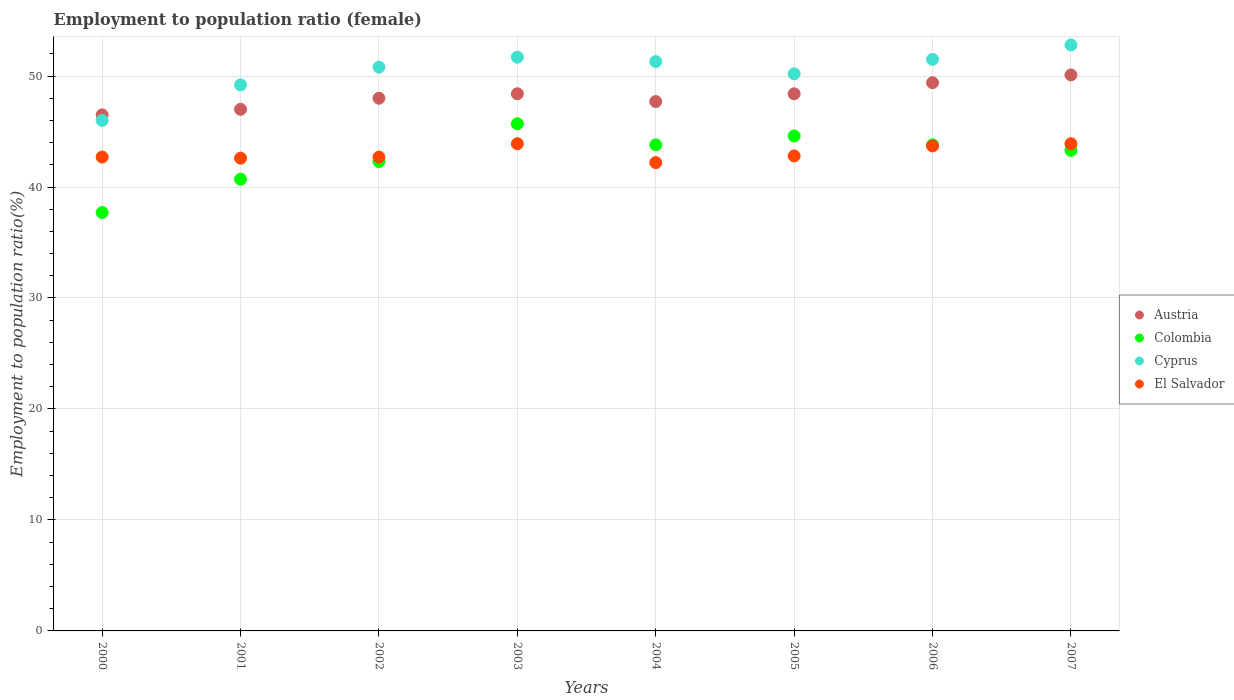How many different coloured dotlines are there?
Provide a succinct answer. 4. Is the number of dotlines equal to the number of legend labels?
Keep it short and to the point. Yes. What is the employment to population ratio in El Salvador in 2004?
Make the answer very short. 42.2. Across all years, what is the maximum employment to population ratio in El Salvador?
Make the answer very short. 43.9. Across all years, what is the minimum employment to population ratio in Colombia?
Offer a very short reply. 37.7. In which year was the employment to population ratio in Colombia maximum?
Offer a terse response. 2003. In which year was the employment to population ratio in Cyprus minimum?
Provide a short and direct response. 2000. What is the total employment to population ratio in El Salvador in the graph?
Provide a short and direct response. 344.5. What is the difference between the employment to population ratio in Cyprus in 2005 and that in 2007?
Your answer should be very brief. -2.6. What is the difference between the employment to population ratio in Colombia in 2006 and the employment to population ratio in El Salvador in 2001?
Make the answer very short. 1.2. What is the average employment to population ratio in Austria per year?
Keep it short and to the point. 48.19. In how many years, is the employment to population ratio in Cyprus greater than 6 %?
Your answer should be compact. 8. What is the ratio of the employment to population ratio in Cyprus in 2003 to that in 2007?
Offer a very short reply. 0.98. What is the difference between the highest and the second highest employment to population ratio in Colombia?
Give a very brief answer. 1.1. What is the difference between the highest and the lowest employment to population ratio in El Salvador?
Give a very brief answer. 1.7. In how many years, is the employment to population ratio in Colombia greater than the average employment to population ratio in Colombia taken over all years?
Offer a terse response. 5. Is it the case that in every year, the sum of the employment to population ratio in Austria and employment to population ratio in Colombia  is greater than the sum of employment to population ratio in Cyprus and employment to population ratio in El Salvador?
Your answer should be compact. No. Is it the case that in every year, the sum of the employment to population ratio in Cyprus and employment to population ratio in Colombia  is greater than the employment to population ratio in Austria?
Ensure brevity in your answer.  Yes. Is the employment to population ratio in El Salvador strictly less than the employment to population ratio in Cyprus over the years?
Your answer should be very brief. Yes. Are the values on the major ticks of Y-axis written in scientific E-notation?
Ensure brevity in your answer.  No. Does the graph contain any zero values?
Your answer should be very brief. No. Does the graph contain grids?
Your answer should be compact. Yes. Where does the legend appear in the graph?
Provide a short and direct response. Center right. How many legend labels are there?
Offer a terse response. 4. What is the title of the graph?
Keep it short and to the point. Employment to population ratio (female). Does "Albania" appear as one of the legend labels in the graph?
Make the answer very short. No. What is the label or title of the Y-axis?
Give a very brief answer. Employment to population ratio(%). What is the Employment to population ratio(%) of Austria in 2000?
Offer a very short reply. 46.5. What is the Employment to population ratio(%) of Colombia in 2000?
Keep it short and to the point. 37.7. What is the Employment to population ratio(%) of El Salvador in 2000?
Provide a short and direct response. 42.7. What is the Employment to population ratio(%) in Colombia in 2001?
Offer a very short reply. 40.7. What is the Employment to population ratio(%) in Cyprus in 2001?
Offer a terse response. 49.2. What is the Employment to population ratio(%) of El Salvador in 2001?
Ensure brevity in your answer.  42.6. What is the Employment to population ratio(%) in Austria in 2002?
Offer a very short reply. 48. What is the Employment to population ratio(%) of Colombia in 2002?
Your response must be concise. 42.3. What is the Employment to population ratio(%) in Cyprus in 2002?
Give a very brief answer. 50.8. What is the Employment to population ratio(%) in El Salvador in 2002?
Your answer should be compact. 42.7. What is the Employment to population ratio(%) of Austria in 2003?
Your response must be concise. 48.4. What is the Employment to population ratio(%) in Colombia in 2003?
Make the answer very short. 45.7. What is the Employment to population ratio(%) of Cyprus in 2003?
Keep it short and to the point. 51.7. What is the Employment to population ratio(%) of El Salvador in 2003?
Your response must be concise. 43.9. What is the Employment to population ratio(%) of Austria in 2004?
Make the answer very short. 47.7. What is the Employment to population ratio(%) of Colombia in 2004?
Your response must be concise. 43.8. What is the Employment to population ratio(%) in Cyprus in 2004?
Your answer should be very brief. 51.3. What is the Employment to population ratio(%) of El Salvador in 2004?
Offer a very short reply. 42.2. What is the Employment to population ratio(%) of Austria in 2005?
Your answer should be very brief. 48.4. What is the Employment to population ratio(%) of Colombia in 2005?
Your response must be concise. 44.6. What is the Employment to population ratio(%) of Cyprus in 2005?
Provide a short and direct response. 50.2. What is the Employment to population ratio(%) in El Salvador in 2005?
Your answer should be compact. 42.8. What is the Employment to population ratio(%) of Austria in 2006?
Offer a terse response. 49.4. What is the Employment to population ratio(%) in Colombia in 2006?
Make the answer very short. 43.8. What is the Employment to population ratio(%) in Cyprus in 2006?
Offer a very short reply. 51.5. What is the Employment to population ratio(%) in El Salvador in 2006?
Your answer should be compact. 43.7. What is the Employment to population ratio(%) of Austria in 2007?
Offer a very short reply. 50.1. What is the Employment to population ratio(%) in Colombia in 2007?
Keep it short and to the point. 43.3. What is the Employment to population ratio(%) of Cyprus in 2007?
Ensure brevity in your answer.  52.8. What is the Employment to population ratio(%) of El Salvador in 2007?
Give a very brief answer. 43.9. Across all years, what is the maximum Employment to population ratio(%) in Austria?
Provide a succinct answer. 50.1. Across all years, what is the maximum Employment to population ratio(%) in Colombia?
Offer a terse response. 45.7. Across all years, what is the maximum Employment to population ratio(%) in Cyprus?
Give a very brief answer. 52.8. Across all years, what is the maximum Employment to population ratio(%) of El Salvador?
Provide a short and direct response. 43.9. Across all years, what is the minimum Employment to population ratio(%) of Austria?
Ensure brevity in your answer.  46.5. Across all years, what is the minimum Employment to population ratio(%) in Colombia?
Your response must be concise. 37.7. Across all years, what is the minimum Employment to population ratio(%) of El Salvador?
Provide a succinct answer. 42.2. What is the total Employment to population ratio(%) in Austria in the graph?
Give a very brief answer. 385.5. What is the total Employment to population ratio(%) of Colombia in the graph?
Your answer should be very brief. 341.9. What is the total Employment to population ratio(%) in Cyprus in the graph?
Give a very brief answer. 403.5. What is the total Employment to population ratio(%) in El Salvador in the graph?
Your response must be concise. 344.5. What is the difference between the Employment to population ratio(%) of Colombia in 2000 and that in 2001?
Provide a short and direct response. -3. What is the difference between the Employment to population ratio(%) of El Salvador in 2000 and that in 2001?
Make the answer very short. 0.1. What is the difference between the Employment to population ratio(%) in Austria in 2000 and that in 2002?
Offer a very short reply. -1.5. What is the difference between the Employment to population ratio(%) of Colombia in 2000 and that in 2003?
Offer a very short reply. -8. What is the difference between the Employment to population ratio(%) of Cyprus in 2000 and that in 2003?
Keep it short and to the point. -5.7. What is the difference between the Employment to population ratio(%) of El Salvador in 2000 and that in 2003?
Offer a very short reply. -1.2. What is the difference between the Employment to population ratio(%) in Colombia in 2000 and that in 2004?
Offer a terse response. -6.1. What is the difference between the Employment to population ratio(%) in Cyprus in 2000 and that in 2004?
Keep it short and to the point. -5.3. What is the difference between the Employment to population ratio(%) of El Salvador in 2000 and that in 2004?
Keep it short and to the point. 0.5. What is the difference between the Employment to population ratio(%) in Austria in 2000 and that in 2005?
Give a very brief answer. -1.9. What is the difference between the Employment to population ratio(%) of El Salvador in 2000 and that in 2005?
Provide a short and direct response. -0.1. What is the difference between the Employment to population ratio(%) in Colombia in 2000 and that in 2006?
Your answer should be very brief. -6.1. What is the difference between the Employment to population ratio(%) in Austria in 2000 and that in 2007?
Your response must be concise. -3.6. What is the difference between the Employment to population ratio(%) of Colombia in 2000 and that in 2007?
Provide a short and direct response. -5.6. What is the difference between the Employment to population ratio(%) of Cyprus in 2000 and that in 2007?
Provide a short and direct response. -6.8. What is the difference between the Employment to population ratio(%) of Austria in 2001 and that in 2002?
Provide a succinct answer. -1. What is the difference between the Employment to population ratio(%) in Cyprus in 2001 and that in 2002?
Your response must be concise. -1.6. What is the difference between the Employment to population ratio(%) in El Salvador in 2001 and that in 2002?
Your answer should be very brief. -0.1. What is the difference between the Employment to population ratio(%) in El Salvador in 2001 and that in 2003?
Your response must be concise. -1.3. What is the difference between the Employment to population ratio(%) of Austria in 2001 and that in 2005?
Offer a terse response. -1.4. What is the difference between the Employment to population ratio(%) of Colombia in 2001 and that in 2005?
Offer a terse response. -3.9. What is the difference between the Employment to population ratio(%) in Colombia in 2001 and that in 2006?
Offer a terse response. -3.1. What is the difference between the Employment to population ratio(%) in Cyprus in 2001 and that in 2006?
Make the answer very short. -2.3. What is the difference between the Employment to population ratio(%) in Austria in 2001 and that in 2007?
Provide a short and direct response. -3.1. What is the difference between the Employment to population ratio(%) in Cyprus in 2001 and that in 2007?
Make the answer very short. -3.6. What is the difference between the Employment to population ratio(%) of El Salvador in 2001 and that in 2007?
Offer a very short reply. -1.3. What is the difference between the Employment to population ratio(%) of Colombia in 2002 and that in 2004?
Your answer should be compact. -1.5. What is the difference between the Employment to population ratio(%) of Cyprus in 2002 and that in 2004?
Provide a succinct answer. -0.5. What is the difference between the Employment to population ratio(%) of El Salvador in 2002 and that in 2004?
Give a very brief answer. 0.5. What is the difference between the Employment to population ratio(%) of Austria in 2002 and that in 2005?
Your answer should be compact. -0.4. What is the difference between the Employment to population ratio(%) of Colombia in 2002 and that in 2005?
Offer a terse response. -2.3. What is the difference between the Employment to population ratio(%) in Cyprus in 2002 and that in 2005?
Keep it short and to the point. 0.6. What is the difference between the Employment to population ratio(%) of El Salvador in 2002 and that in 2005?
Offer a very short reply. -0.1. What is the difference between the Employment to population ratio(%) in Austria in 2002 and that in 2006?
Keep it short and to the point. -1.4. What is the difference between the Employment to population ratio(%) in Cyprus in 2002 and that in 2006?
Give a very brief answer. -0.7. What is the difference between the Employment to population ratio(%) in Austria in 2002 and that in 2007?
Provide a short and direct response. -2.1. What is the difference between the Employment to population ratio(%) of Colombia in 2002 and that in 2007?
Provide a succinct answer. -1. What is the difference between the Employment to population ratio(%) in El Salvador in 2002 and that in 2007?
Your answer should be compact. -1.2. What is the difference between the Employment to population ratio(%) of Austria in 2003 and that in 2004?
Make the answer very short. 0.7. What is the difference between the Employment to population ratio(%) in Cyprus in 2003 and that in 2004?
Ensure brevity in your answer.  0.4. What is the difference between the Employment to population ratio(%) of Austria in 2003 and that in 2005?
Keep it short and to the point. 0. What is the difference between the Employment to population ratio(%) of Colombia in 2003 and that in 2005?
Your response must be concise. 1.1. What is the difference between the Employment to population ratio(%) of Austria in 2003 and that in 2006?
Give a very brief answer. -1. What is the difference between the Employment to population ratio(%) in Colombia in 2003 and that in 2006?
Provide a short and direct response. 1.9. What is the difference between the Employment to population ratio(%) of Cyprus in 2003 and that in 2006?
Your response must be concise. 0.2. What is the difference between the Employment to population ratio(%) in El Salvador in 2003 and that in 2006?
Offer a very short reply. 0.2. What is the difference between the Employment to population ratio(%) in Cyprus in 2003 and that in 2007?
Your response must be concise. -1.1. What is the difference between the Employment to population ratio(%) of El Salvador in 2003 and that in 2007?
Offer a terse response. 0. What is the difference between the Employment to population ratio(%) in El Salvador in 2004 and that in 2005?
Ensure brevity in your answer.  -0.6. What is the difference between the Employment to population ratio(%) in Austria in 2004 and that in 2006?
Make the answer very short. -1.7. What is the difference between the Employment to population ratio(%) of Cyprus in 2004 and that in 2006?
Provide a short and direct response. -0.2. What is the difference between the Employment to population ratio(%) of Austria in 2004 and that in 2007?
Your response must be concise. -2.4. What is the difference between the Employment to population ratio(%) in Colombia in 2004 and that in 2007?
Ensure brevity in your answer.  0.5. What is the difference between the Employment to population ratio(%) in Austria in 2005 and that in 2006?
Offer a very short reply. -1. What is the difference between the Employment to population ratio(%) of Colombia in 2005 and that in 2006?
Keep it short and to the point. 0.8. What is the difference between the Employment to population ratio(%) of El Salvador in 2005 and that in 2006?
Give a very brief answer. -0.9. What is the difference between the Employment to population ratio(%) in Colombia in 2005 and that in 2007?
Ensure brevity in your answer.  1.3. What is the difference between the Employment to population ratio(%) in Austria in 2006 and that in 2007?
Keep it short and to the point. -0.7. What is the difference between the Employment to population ratio(%) of El Salvador in 2006 and that in 2007?
Offer a very short reply. -0.2. What is the difference between the Employment to population ratio(%) in Colombia in 2000 and the Employment to population ratio(%) in El Salvador in 2001?
Your response must be concise. -4.9. What is the difference between the Employment to population ratio(%) of Cyprus in 2000 and the Employment to population ratio(%) of El Salvador in 2001?
Your response must be concise. 3.4. What is the difference between the Employment to population ratio(%) of Austria in 2000 and the Employment to population ratio(%) of Cyprus in 2003?
Your answer should be very brief. -5.2. What is the difference between the Employment to population ratio(%) in Colombia in 2000 and the Employment to population ratio(%) in El Salvador in 2003?
Provide a short and direct response. -6.2. What is the difference between the Employment to population ratio(%) of Cyprus in 2000 and the Employment to population ratio(%) of El Salvador in 2004?
Offer a terse response. 3.8. What is the difference between the Employment to population ratio(%) in Austria in 2000 and the Employment to population ratio(%) in Colombia in 2005?
Offer a terse response. 1.9. What is the difference between the Employment to population ratio(%) of Austria in 2000 and the Employment to population ratio(%) of El Salvador in 2005?
Make the answer very short. 3.7. What is the difference between the Employment to population ratio(%) of Colombia in 2000 and the Employment to population ratio(%) of Cyprus in 2005?
Ensure brevity in your answer.  -12.5. What is the difference between the Employment to population ratio(%) of Colombia in 2000 and the Employment to population ratio(%) of El Salvador in 2005?
Offer a very short reply. -5.1. What is the difference between the Employment to population ratio(%) of Austria in 2000 and the Employment to population ratio(%) of Cyprus in 2006?
Your answer should be very brief. -5. What is the difference between the Employment to population ratio(%) of Austria in 2000 and the Employment to population ratio(%) of El Salvador in 2006?
Your answer should be very brief. 2.8. What is the difference between the Employment to population ratio(%) in Colombia in 2000 and the Employment to population ratio(%) in Cyprus in 2006?
Keep it short and to the point. -13.8. What is the difference between the Employment to population ratio(%) in Austria in 2000 and the Employment to population ratio(%) in Colombia in 2007?
Offer a very short reply. 3.2. What is the difference between the Employment to population ratio(%) in Austria in 2000 and the Employment to population ratio(%) in El Salvador in 2007?
Your answer should be compact. 2.6. What is the difference between the Employment to population ratio(%) in Colombia in 2000 and the Employment to population ratio(%) in Cyprus in 2007?
Provide a succinct answer. -15.1. What is the difference between the Employment to population ratio(%) of Austria in 2001 and the Employment to population ratio(%) of Colombia in 2002?
Provide a short and direct response. 4.7. What is the difference between the Employment to population ratio(%) in Austria in 2001 and the Employment to population ratio(%) in Cyprus in 2002?
Your answer should be very brief. -3.8. What is the difference between the Employment to population ratio(%) in Colombia in 2001 and the Employment to population ratio(%) in Cyprus in 2002?
Your answer should be very brief. -10.1. What is the difference between the Employment to population ratio(%) in Cyprus in 2001 and the Employment to population ratio(%) in El Salvador in 2002?
Provide a short and direct response. 6.5. What is the difference between the Employment to population ratio(%) in Cyprus in 2001 and the Employment to population ratio(%) in El Salvador in 2003?
Your response must be concise. 5.3. What is the difference between the Employment to population ratio(%) of Austria in 2001 and the Employment to population ratio(%) of Cyprus in 2004?
Provide a short and direct response. -4.3. What is the difference between the Employment to population ratio(%) of Colombia in 2001 and the Employment to population ratio(%) of El Salvador in 2004?
Ensure brevity in your answer.  -1.5. What is the difference between the Employment to population ratio(%) of Austria in 2001 and the Employment to population ratio(%) of Cyprus in 2005?
Make the answer very short. -3.2. What is the difference between the Employment to population ratio(%) of Austria in 2001 and the Employment to population ratio(%) of El Salvador in 2005?
Give a very brief answer. 4.2. What is the difference between the Employment to population ratio(%) in Colombia in 2001 and the Employment to population ratio(%) in Cyprus in 2005?
Offer a terse response. -9.5. What is the difference between the Employment to population ratio(%) in Colombia in 2001 and the Employment to population ratio(%) in El Salvador in 2005?
Your answer should be compact. -2.1. What is the difference between the Employment to population ratio(%) in Cyprus in 2001 and the Employment to population ratio(%) in El Salvador in 2005?
Your answer should be very brief. 6.4. What is the difference between the Employment to population ratio(%) in Austria in 2001 and the Employment to population ratio(%) in Colombia in 2006?
Keep it short and to the point. 3.2. What is the difference between the Employment to population ratio(%) of Austria in 2001 and the Employment to population ratio(%) of El Salvador in 2006?
Offer a terse response. 3.3. What is the difference between the Employment to population ratio(%) in Colombia in 2001 and the Employment to population ratio(%) in Cyprus in 2006?
Give a very brief answer. -10.8. What is the difference between the Employment to population ratio(%) in Cyprus in 2001 and the Employment to population ratio(%) in El Salvador in 2006?
Make the answer very short. 5.5. What is the difference between the Employment to population ratio(%) of Austria in 2001 and the Employment to population ratio(%) of Cyprus in 2007?
Offer a very short reply. -5.8. What is the difference between the Employment to population ratio(%) of Austria in 2001 and the Employment to population ratio(%) of El Salvador in 2007?
Your response must be concise. 3.1. What is the difference between the Employment to population ratio(%) of Colombia in 2001 and the Employment to population ratio(%) of Cyprus in 2007?
Your response must be concise. -12.1. What is the difference between the Employment to population ratio(%) of Cyprus in 2001 and the Employment to population ratio(%) of El Salvador in 2007?
Provide a succinct answer. 5.3. What is the difference between the Employment to population ratio(%) of Austria in 2002 and the Employment to population ratio(%) of Cyprus in 2003?
Ensure brevity in your answer.  -3.7. What is the difference between the Employment to population ratio(%) in Austria in 2002 and the Employment to population ratio(%) in El Salvador in 2003?
Your answer should be compact. 4.1. What is the difference between the Employment to population ratio(%) of Colombia in 2002 and the Employment to population ratio(%) of El Salvador in 2003?
Offer a very short reply. -1.6. What is the difference between the Employment to population ratio(%) of Austria in 2002 and the Employment to population ratio(%) of Cyprus in 2004?
Provide a succinct answer. -3.3. What is the difference between the Employment to population ratio(%) of Colombia in 2002 and the Employment to population ratio(%) of Cyprus in 2004?
Offer a terse response. -9. What is the difference between the Employment to population ratio(%) in Colombia in 2002 and the Employment to population ratio(%) in El Salvador in 2004?
Make the answer very short. 0.1. What is the difference between the Employment to population ratio(%) of Austria in 2002 and the Employment to population ratio(%) of Colombia in 2006?
Make the answer very short. 4.2. What is the difference between the Employment to population ratio(%) in Austria in 2002 and the Employment to population ratio(%) in Cyprus in 2006?
Offer a very short reply. -3.5. What is the difference between the Employment to population ratio(%) of Colombia in 2002 and the Employment to population ratio(%) of El Salvador in 2006?
Offer a very short reply. -1.4. What is the difference between the Employment to population ratio(%) of Cyprus in 2002 and the Employment to population ratio(%) of El Salvador in 2006?
Your answer should be compact. 7.1. What is the difference between the Employment to population ratio(%) in Austria in 2002 and the Employment to population ratio(%) in Colombia in 2007?
Provide a short and direct response. 4.7. What is the difference between the Employment to population ratio(%) of Austria in 2002 and the Employment to population ratio(%) of Cyprus in 2007?
Your answer should be compact. -4.8. What is the difference between the Employment to population ratio(%) of Austria in 2002 and the Employment to population ratio(%) of El Salvador in 2007?
Offer a very short reply. 4.1. What is the difference between the Employment to population ratio(%) in Colombia in 2002 and the Employment to population ratio(%) in Cyprus in 2007?
Keep it short and to the point. -10.5. What is the difference between the Employment to population ratio(%) of Austria in 2003 and the Employment to population ratio(%) of Colombia in 2004?
Your answer should be very brief. 4.6. What is the difference between the Employment to population ratio(%) of Austria in 2003 and the Employment to population ratio(%) of El Salvador in 2004?
Your response must be concise. 6.2. What is the difference between the Employment to population ratio(%) of Colombia in 2003 and the Employment to population ratio(%) of Cyprus in 2004?
Offer a very short reply. -5.6. What is the difference between the Employment to population ratio(%) of Colombia in 2003 and the Employment to population ratio(%) of El Salvador in 2004?
Give a very brief answer. 3.5. What is the difference between the Employment to population ratio(%) of Austria in 2003 and the Employment to population ratio(%) of El Salvador in 2005?
Your response must be concise. 5.6. What is the difference between the Employment to population ratio(%) in Cyprus in 2003 and the Employment to population ratio(%) in El Salvador in 2005?
Offer a terse response. 8.9. What is the difference between the Employment to population ratio(%) in Colombia in 2003 and the Employment to population ratio(%) in El Salvador in 2006?
Offer a terse response. 2. What is the difference between the Employment to population ratio(%) in Austria in 2003 and the Employment to population ratio(%) in Colombia in 2007?
Keep it short and to the point. 5.1. What is the difference between the Employment to population ratio(%) of Austria in 2003 and the Employment to population ratio(%) of Cyprus in 2007?
Your answer should be compact. -4.4. What is the difference between the Employment to population ratio(%) of Austria in 2003 and the Employment to population ratio(%) of El Salvador in 2007?
Ensure brevity in your answer.  4.5. What is the difference between the Employment to population ratio(%) of Colombia in 2003 and the Employment to population ratio(%) of El Salvador in 2007?
Offer a very short reply. 1.8. What is the difference between the Employment to population ratio(%) of Cyprus in 2003 and the Employment to population ratio(%) of El Salvador in 2007?
Keep it short and to the point. 7.8. What is the difference between the Employment to population ratio(%) of Austria in 2004 and the Employment to population ratio(%) of Colombia in 2005?
Ensure brevity in your answer.  3.1. What is the difference between the Employment to population ratio(%) in Austria in 2004 and the Employment to population ratio(%) in Cyprus in 2005?
Keep it short and to the point. -2.5. What is the difference between the Employment to population ratio(%) in Colombia in 2004 and the Employment to population ratio(%) in Cyprus in 2005?
Give a very brief answer. -6.4. What is the difference between the Employment to population ratio(%) in Colombia in 2004 and the Employment to population ratio(%) in El Salvador in 2005?
Ensure brevity in your answer.  1. What is the difference between the Employment to population ratio(%) in Cyprus in 2004 and the Employment to population ratio(%) in El Salvador in 2005?
Keep it short and to the point. 8.5. What is the difference between the Employment to population ratio(%) of Austria in 2004 and the Employment to population ratio(%) of Colombia in 2006?
Ensure brevity in your answer.  3.9. What is the difference between the Employment to population ratio(%) in Colombia in 2004 and the Employment to population ratio(%) in Cyprus in 2006?
Your response must be concise. -7.7. What is the difference between the Employment to population ratio(%) in Colombia in 2004 and the Employment to population ratio(%) in El Salvador in 2006?
Offer a terse response. 0.1. What is the difference between the Employment to population ratio(%) in Cyprus in 2004 and the Employment to population ratio(%) in El Salvador in 2007?
Provide a short and direct response. 7.4. What is the difference between the Employment to population ratio(%) in Austria in 2005 and the Employment to population ratio(%) in Colombia in 2006?
Ensure brevity in your answer.  4.6. What is the difference between the Employment to population ratio(%) of Austria in 2005 and the Employment to population ratio(%) of El Salvador in 2006?
Provide a succinct answer. 4.7. What is the difference between the Employment to population ratio(%) in Colombia in 2005 and the Employment to population ratio(%) in Cyprus in 2006?
Your answer should be very brief. -6.9. What is the difference between the Employment to population ratio(%) of Colombia in 2005 and the Employment to population ratio(%) of El Salvador in 2006?
Provide a succinct answer. 0.9. What is the difference between the Employment to population ratio(%) in Cyprus in 2005 and the Employment to population ratio(%) in El Salvador in 2006?
Offer a very short reply. 6.5. What is the difference between the Employment to population ratio(%) in Austria in 2005 and the Employment to population ratio(%) in Cyprus in 2007?
Give a very brief answer. -4.4. What is the difference between the Employment to population ratio(%) in Austria in 2005 and the Employment to population ratio(%) in El Salvador in 2007?
Your answer should be very brief. 4.5. What is the difference between the Employment to population ratio(%) of Colombia in 2005 and the Employment to population ratio(%) of Cyprus in 2007?
Offer a very short reply. -8.2. What is the difference between the Employment to population ratio(%) in Colombia in 2005 and the Employment to population ratio(%) in El Salvador in 2007?
Give a very brief answer. 0.7. What is the difference between the Employment to population ratio(%) of Cyprus in 2005 and the Employment to population ratio(%) of El Salvador in 2007?
Keep it short and to the point. 6.3. What is the difference between the Employment to population ratio(%) in Austria in 2006 and the Employment to population ratio(%) in Cyprus in 2007?
Keep it short and to the point. -3.4. What is the difference between the Employment to population ratio(%) of Cyprus in 2006 and the Employment to population ratio(%) of El Salvador in 2007?
Give a very brief answer. 7.6. What is the average Employment to population ratio(%) in Austria per year?
Offer a very short reply. 48.19. What is the average Employment to population ratio(%) of Colombia per year?
Your answer should be very brief. 42.74. What is the average Employment to population ratio(%) in Cyprus per year?
Your answer should be compact. 50.44. What is the average Employment to population ratio(%) in El Salvador per year?
Your answer should be very brief. 43.06. In the year 2000, what is the difference between the Employment to population ratio(%) of Austria and Employment to population ratio(%) of Colombia?
Keep it short and to the point. 8.8. In the year 2000, what is the difference between the Employment to population ratio(%) of Cyprus and Employment to population ratio(%) of El Salvador?
Make the answer very short. 3.3. In the year 2001, what is the difference between the Employment to population ratio(%) of Austria and Employment to population ratio(%) of Cyprus?
Provide a short and direct response. -2.2. In the year 2001, what is the difference between the Employment to population ratio(%) of Colombia and Employment to population ratio(%) of Cyprus?
Offer a terse response. -8.5. In the year 2001, what is the difference between the Employment to population ratio(%) of Cyprus and Employment to population ratio(%) of El Salvador?
Give a very brief answer. 6.6. In the year 2002, what is the difference between the Employment to population ratio(%) of Austria and Employment to population ratio(%) of El Salvador?
Offer a terse response. 5.3. In the year 2002, what is the difference between the Employment to population ratio(%) of Colombia and Employment to population ratio(%) of Cyprus?
Offer a very short reply. -8.5. In the year 2002, what is the difference between the Employment to population ratio(%) of Cyprus and Employment to population ratio(%) of El Salvador?
Provide a short and direct response. 8.1. In the year 2003, what is the difference between the Employment to population ratio(%) in Austria and Employment to population ratio(%) in Cyprus?
Your answer should be very brief. -3.3. In the year 2003, what is the difference between the Employment to population ratio(%) in Colombia and Employment to population ratio(%) in Cyprus?
Your answer should be very brief. -6. In the year 2003, what is the difference between the Employment to population ratio(%) in Colombia and Employment to population ratio(%) in El Salvador?
Your answer should be compact. 1.8. In the year 2004, what is the difference between the Employment to population ratio(%) of Austria and Employment to population ratio(%) of Cyprus?
Your response must be concise. -3.6. In the year 2004, what is the difference between the Employment to population ratio(%) of Austria and Employment to population ratio(%) of El Salvador?
Keep it short and to the point. 5.5. In the year 2004, what is the difference between the Employment to population ratio(%) of Colombia and Employment to population ratio(%) of Cyprus?
Your answer should be very brief. -7.5. In the year 2004, what is the difference between the Employment to population ratio(%) of Colombia and Employment to population ratio(%) of El Salvador?
Make the answer very short. 1.6. In the year 2004, what is the difference between the Employment to population ratio(%) of Cyprus and Employment to population ratio(%) of El Salvador?
Give a very brief answer. 9.1. In the year 2005, what is the difference between the Employment to population ratio(%) of Austria and Employment to population ratio(%) of Colombia?
Make the answer very short. 3.8. In the year 2005, what is the difference between the Employment to population ratio(%) of Austria and Employment to population ratio(%) of Cyprus?
Your answer should be very brief. -1.8. In the year 2005, what is the difference between the Employment to population ratio(%) in Colombia and Employment to population ratio(%) in Cyprus?
Provide a short and direct response. -5.6. In the year 2006, what is the difference between the Employment to population ratio(%) in Austria and Employment to population ratio(%) in Colombia?
Keep it short and to the point. 5.6. In the year 2006, what is the difference between the Employment to population ratio(%) of Austria and Employment to population ratio(%) of Cyprus?
Give a very brief answer. -2.1. In the year 2006, what is the difference between the Employment to population ratio(%) of Colombia and Employment to population ratio(%) of Cyprus?
Provide a short and direct response. -7.7. In the year 2006, what is the difference between the Employment to population ratio(%) in Cyprus and Employment to population ratio(%) in El Salvador?
Ensure brevity in your answer.  7.8. In the year 2007, what is the difference between the Employment to population ratio(%) of Austria and Employment to population ratio(%) of Cyprus?
Make the answer very short. -2.7. In the year 2007, what is the difference between the Employment to population ratio(%) of Cyprus and Employment to population ratio(%) of El Salvador?
Provide a succinct answer. 8.9. What is the ratio of the Employment to population ratio(%) in Austria in 2000 to that in 2001?
Your answer should be compact. 0.99. What is the ratio of the Employment to population ratio(%) of Colombia in 2000 to that in 2001?
Make the answer very short. 0.93. What is the ratio of the Employment to population ratio(%) in Cyprus in 2000 to that in 2001?
Your answer should be very brief. 0.94. What is the ratio of the Employment to population ratio(%) in Austria in 2000 to that in 2002?
Your answer should be compact. 0.97. What is the ratio of the Employment to population ratio(%) of Colombia in 2000 to that in 2002?
Give a very brief answer. 0.89. What is the ratio of the Employment to population ratio(%) in Cyprus in 2000 to that in 2002?
Your response must be concise. 0.91. What is the ratio of the Employment to population ratio(%) of El Salvador in 2000 to that in 2002?
Your response must be concise. 1. What is the ratio of the Employment to population ratio(%) of Austria in 2000 to that in 2003?
Your answer should be compact. 0.96. What is the ratio of the Employment to population ratio(%) in Colombia in 2000 to that in 2003?
Your response must be concise. 0.82. What is the ratio of the Employment to population ratio(%) of Cyprus in 2000 to that in 2003?
Ensure brevity in your answer.  0.89. What is the ratio of the Employment to population ratio(%) in El Salvador in 2000 to that in 2003?
Your answer should be very brief. 0.97. What is the ratio of the Employment to population ratio(%) of Austria in 2000 to that in 2004?
Your answer should be compact. 0.97. What is the ratio of the Employment to population ratio(%) of Colombia in 2000 to that in 2004?
Offer a very short reply. 0.86. What is the ratio of the Employment to population ratio(%) of Cyprus in 2000 to that in 2004?
Make the answer very short. 0.9. What is the ratio of the Employment to population ratio(%) in El Salvador in 2000 to that in 2004?
Your answer should be compact. 1.01. What is the ratio of the Employment to population ratio(%) in Austria in 2000 to that in 2005?
Provide a short and direct response. 0.96. What is the ratio of the Employment to population ratio(%) of Colombia in 2000 to that in 2005?
Ensure brevity in your answer.  0.85. What is the ratio of the Employment to population ratio(%) in Cyprus in 2000 to that in 2005?
Provide a succinct answer. 0.92. What is the ratio of the Employment to population ratio(%) of Austria in 2000 to that in 2006?
Provide a short and direct response. 0.94. What is the ratio of the Employment to population ratio(%) in Colombia in 2000 to that in 2006?
Your answer should be very brief. 0.86. What is the ratio of the Employment to population ratio(%) in Cyprus in 2000 to that in 2006?
Your response must be concise. 0.89. What is the ratio of the Employment to population ratio(%) in El Salvador in 2000 to that in 2006?
Your answer should be very brief. 0.98. What is the ratio of the Employment to population ratio(%) in Austria in 2000 to that in 2007?
Ensure brevity in your answer.  0.93. What is the ratio of the Employment to population ratio(%) of Colombia in 2000 to that in 2007?
Make the answer very short. 0.87. What is the ratio of the Employment to population ratio(%) of Cyprus in 2000 to that in 2007?
Ensure brevity in your answer.  0.87. What is the ratio of the Employment to population ratio(%) of El Salvador in 2000 to that in 2007?
Your answer should be very brief. 0.97. What is the ratio of the Employment to population ratio(%) of Austria in 2001 to that in 2002?
Provide a short and direct response. 0.98. What is the ratio of the Employment to population ratio(%) in Colombia in 2001 to that in 2002?
Your response must be concise. 0.96. What is the ratio of the Employment to population ratio(%) in Cyprus in 2001 to that in 2002?
Provide a succinct answer. 0.97. What is the ratio of the Employment to population ratio(%) in Austria in 2001 to that in 2003?
Offer a very short reply. 0.97. What is the ratio of the Employment to population ratio(%) in Colombia in 2001 to that in 2003?
Provide a succinct answer. 0.89. What is the ratio of the Employment to population ratio(%) in Cyprus in 2001 to that in 2003?
Ensure brevity in your answer.  0.95. What is the ratio of the Employment to population ratio(%) of El Salvador in 2001 to that in 2003?
Give a very brief answer. 0.97. What is the ratio of the Employment to population ratio(%) of Austria in 2001 to that in 2004?
Keep it short and to the point. 0.99. What is the ratio of the Employment to population ratio(%) in Colombia in 2001 to that in 2004?
Your answer should be very brief. 0.93. What is the ratio of the Employment to population ratio(%) of Cyprus in 2001 to that in 2004?
Offer a terse response. 0.96. What is the ratio of the Employment to population ratio(%) in El Salvador in 2001 to that in 2004?
Make the answer very short. 1.01. What is the ratio of the Employment to population ratio(%) in Austria in 2001 to that in 2005?
Offer a terse response. 0.97. What is the ratio of the Employment to population ratio(%) in Colombia in 2001 to that in 2005?
Provide a short and direct response. 0.91. What is the ratio of the Employment to population ratio(%) of Cyprus in 2001 to that in 2005?
Your answer should be very brief. 0.98. What is the ratio of the Employment to population ratio(%) in Austria in 2001 to that in 2006?
Offer a very short reply. 0.95. What is the ratio of the Employment to population ratio(%) in Colombia in 2001 to that in 2006?
Make the answer very short. 0.93. What is the ratio of the Employment to population ratio(%) of Cyprus in 2001 to that in 2006?
Provide a succinct answer. 0.96. What is the ratio of the Employment to population ratio(%) in El Salvador in 2001 to that in 2006?
Make the answer very short. 0.97. What is the ratio of the Employment to population ratio(%) in Austria in 2001 to that in 2007?
Ensure brevity in your answer.  0.94. What is the ratio of the Employment to population ratio(%) in Cyprus in 2001 to that in 2007?
Your response must be concise. 0.93. What is the ratio of the Employment to population ratio(%) in El Salvador in 2001 to that in 2007?
Make the answer very short. 0.97. What is the ratio of the Employment to population ratio(%) of Colombia in 2002 to that in 2003?
Provide a succinct answer. 0.93. What is the ratio of the Employment to population ratio(%) of Cyprus in 2002 to that in 2003?
Ensure brevity in your answer.  0.98. What is the ratio of the Employment to population ratio(%) of El Salvador in 2002 to that in 2003?
Ensure brevity in your answer.  0.97. What is the ratio of the Employment to population ratio(%) of Colombia in 2002 to that in 2004?
Your response must be concise. 0.97. What is the ratio of the Employment to population ratio(%) of Cyprus in 2002 to that in 2004?
Your answer should be very brief. 0.99. What is the ratio of the Employment to population ratio(%) of El Salvador in 2002 to that in 2004?
Provide a succinct answer. 1.01. What is the ratio of the Employment to population ratio(%) of Austria in 2002 to that in 2005?
Ensure brevity in your answer.  0.99. What is the ratio of the Employment to population ratio(%) in Colombia in 2002 to that in 2005?
Provide a succinct answer. 0.95. What is the ratio of the Employment to population ratio(%) in El Salvador in 2002 to that in 2005?
Offer a terse response. 1. What is the ratio of the Employment to population ratio(%) of Austria in 2002 to that in 2006?
Give a very brief answer. 0.97. What is the ratio of the Employment to population ratio(%) in Colombia in 2002 to that in 2006?
Your answer should be very brief. 0.97. What is the ratio of the Employment to population ratio(%) in Cyprus in 2002 to that in 2006?
Provide a succinct answer. 0.99. What is the ratio of the Employment to population ratio(%) in El Salvador in 2002 to that in 2006?
Your response must be concise. 0.98. What is the ratio of the Employment to population ratio(%) of Austria in 2002 to that in 2007?
Give a very brief answer. 0.96. What is the ratio of the Employment to population ratio(%) of Colombia in 2002 to that in 2007?
Ensure brevity in your answer.  0.98. What is the ratio of the Employment to population ratio(%) of Cyprus in 2002 to that in 2007?
Provide a succinct answer. 0.96. What is the ratio of the Employment to population ratio(%) of El Salvador in 2002 to that in 2007?
Your response must be concise. 0.97. What is the ratio of the Employment to population ratio(%) in Austria in 2003 to that in 2004?
Offer a terse response. 1.01. What is the ratio of the Employment to population ratio(%) of Colombia in 2003 to that in 2004?
Make the answer very short. 1.04. What is the ratio of the Employment to population ratio(%) in Cyprus in 2003 to that in 2004?
Your answer should be very brief. 1.01. What is the ratio of the Employment to population ratio(%) in El Salvador in 2003 to that in 2004?
Offer a very short reply. 1.04. What is the ratio of the Employment to population ratio(%) of Austria in 2003 to that in 2005?
Your answer should be very brief. 1. What is the ratio of the Employment to population ratio(%) in Colombia in 2003 to that in 2005?
Offer a terse response. 1.02. What is the ratio of the Employment to population ratio(%) of Cyprus in 2003 to that in 2005?
Keep it short and to the point. 1.03. What is the ratio of the Employment to population ratio(%) of El Salvador in 2003 to that in 2005?
Keep it short and to the point. 1.03. What is the ratio of the Employment to population ratio(%) of Austria in 2003 to that in 2006?
Offer a terse response. 0.98. What is the ratio of the Employment to population ratio(%) in Colombia in 2003 to that in 2006?
Provide a succinct answer. 1.04. What is the ratio of the Employment to population ratio(%) in Cyprus in 2003 to that in 2006?
Offer a very short reply. 1. What is the ratio of the Employment to population ratio(%) of Austria in 2003 to that in 2007?
Your answer should be very brief. 0.97. What is the ratio of the Employment to population ratio(%) of Colombia in 2003 to that in 2007?
Make the answer very short. 1.06. What is the ratio of the Employment to population ratio(%) of Cyprus in 2003 to that in 2007?
Your answer should be very brief. 0.98. What is the ratio of the Employment to population ratio(%) in Austria in 2004 to that in 2005?
Offer a terse response. 0.99. What is the ratio of the Employment to population ratio(%) of Colombia in 2004 to that in 2005?
Offer a terse response. 0.98. What is the ratio of the Employment to population ratio(%) of Cyprus in 2004 to that in 2005?
Make the answer very short. 1.02. What is the ratio of the Employment to population ratio(%) of Austria in 2004 to that in 2006?
Give a very brief answer. 0.97. What is the ratio of the Employment to population ratio(%) of Colombia in 2004 to that in 2006?
Provide a short and direct response. 1. What is the ratio of the Employment to population ratio(%) in El Salvador in 2004 to that in 2006?
Ensure brevity in your answer.  0.97. What is the ratio of the Employment to population ratio(%) of Austria in 2004 to that in 2007?
Provide a succinct answer. 0.95. What is the ratio of the Employment to population ratio(%) in Colombia in 2004 to that in 2007?
Ensure brevity in your answer.  1.01. What is the ratio of the Employment to population ratio(%) of Cyprus in 2004 to that in 2007?
Offer a terse response. 0.97. What is the ratio of the Employment to population ratio(%) of El Salvador in 2004 to that in 2007?
Keep it short and to the point. 0.96. What is the ratio of the Employment to population ratio(%) in Austria in 2005 to that in 2006?
Provide a succinct answer. 0.98. What is the ratio of the Employment to population ratio(%) of Colombia in 2005 to that in 2006?
Provide a succinct answer. 1.02. What is the ratio of the Employment to population ratio(%) of Cyprus in 2005 to that in 2006?
Make the answer very short. 0.97. What is the ratio of the Employment to population ratio(%) of El Salvador in 2005 to that in 2006?
Your answer should be compact. 0.98. What is the ratio of the Employment to population ratio(%) in Austria in 2005 to that in 2007?
Offer a terse response. 0.97. What is the ratio of the Employment to population ratio(%) in Cyprus in 2005 to that in 2007?
Ensure brevity in your answer.  0.95. What is the ratio of the Employment to population ratio(%) in El Salvador in 2005 to that in 2007?
Ensure brevity in your answer.  0.97. What is the ratio of the Employment to population ratio(%) of Austria in 2006 to that in 2007?
Give a very brief answer. 0.99. What is the ratio of the Employment to population ratio(%) of Colombia in 2006 to that in 2007?
Your response must be concise. 1.01. What is the ratio of the Employment to population ratio(%) in Cyprus in 2006 to that in 2007?
Make the answer very short. 0.98. What is the difference between the highest and the second highest Employment to population ratio(%) of Austria?
Your answer should be very brief. 0.7. What is the difference between the highest and the second highest Employment to population ratio(%) of Cyprus?
Provide a short and direct response. 1.1. What is the difference between the highest and the second highest Employment to population ratio(%) of El Salvador?
Provide a succinct answer. 0. What is the difference between the highest and the lowest Employment to population ratio(%) of El Salvador?
Offer a very short reply. 1.7. 